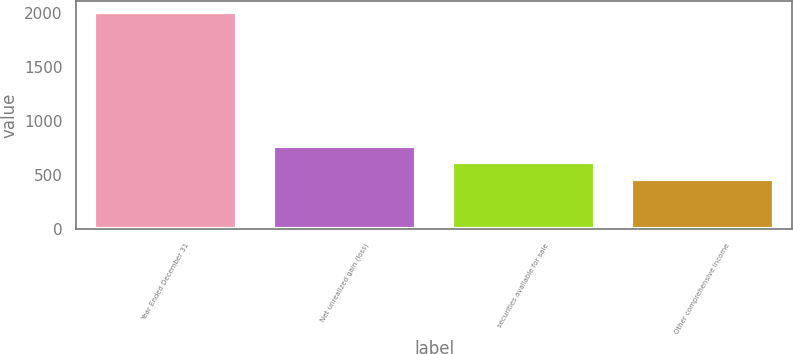<chart> <loc_0><loc_0><loc_500><loc_500><bar_chart><fcel>Year Ended December 31<fcel>Net unrealized gain (loss)<fcel>securities available for sale<fcel>Other comprehensive income<nl><fcel>2013<fcel>773.8<fcel>618.9<fcel>464<nl></chart> 